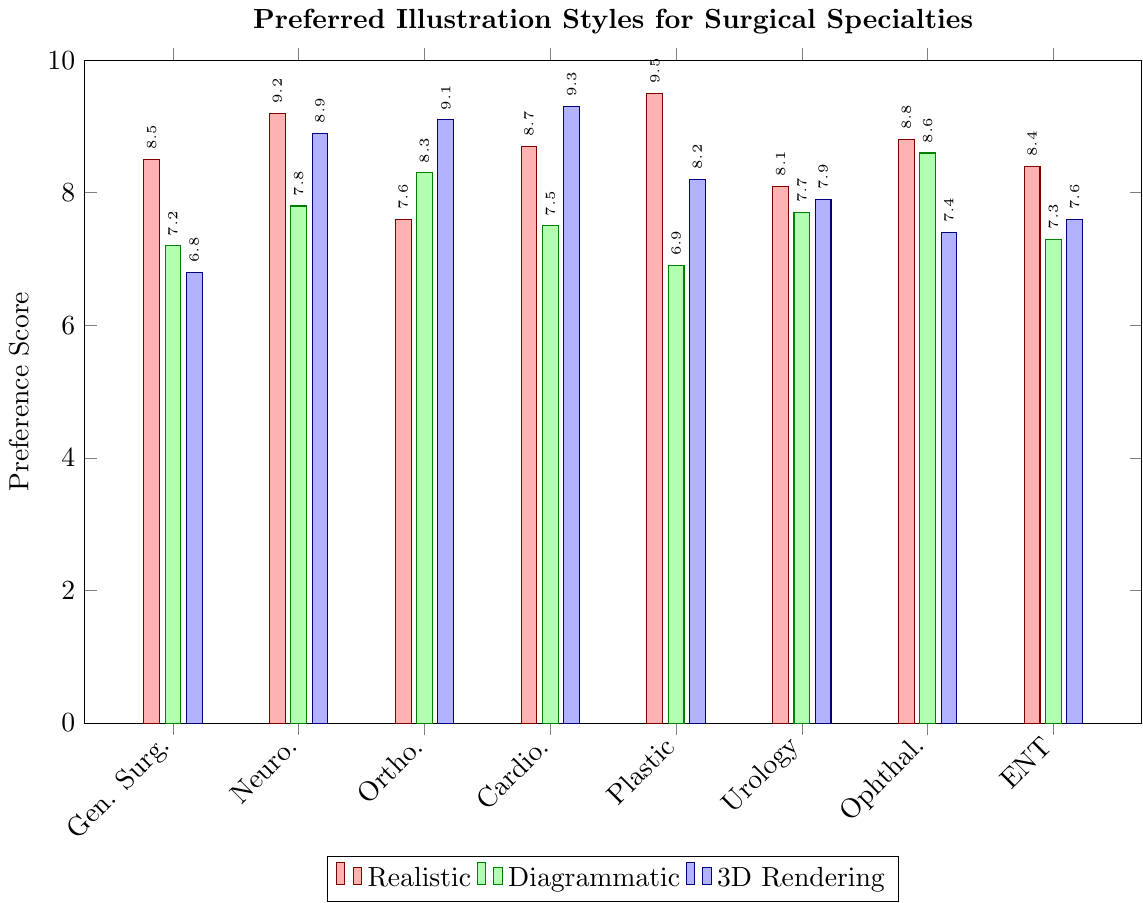Which surgical specialty prefers the realistic illustration style the most? To find the surgical specialty that prefers realistic illustrations the most, look at the "Realistic" bars and identify the tallest bar. The bar for Plastic Surgery is the tallest.
Answer: Plastic Surgery Which illustration style is least preferred by General Surgery? Look at the bars corresponding to General Surgery and identify the shortest one. The "3D Rendering" bar is the shortest for General Surgery.
Answer: 3D Rendering What's the average preference score for Neurosurgery across all illustration styles? Sum all preference scores for Neurosurgery and divide by the number of styles (3). Preference scores are 9.2 (Realistic), 7.8 (Diagrammatic), and 8.9 (3D Rendering). So, (9.2 + 7.8 + 8.9) / 3 = 25.9 / 3 = 8.63.
Answer: 8.63 Which specialty has the highest overall preference for 3D Rendering? To find this, look at the "3D Rendering" bars and identify the tallest one. The tallest "3D Rendering" bar corresponds to Cardiothoracic Surgery.
Answer: Cardiothoracic Surgery How does the preference for Diagrammatic illustrations in Urology compare with that in Ophthalmology? Compare the height of the "Diagrammatic" bars for Urology and Ophthalmology. Urology's score is 7.7, while Ophthalmology's score is 8.6. 8.6 is greater than 7.7.
Answer: Ophthalmology prefers it more What is the total preference score for all illustration styles in ENT? Sum up all the preference scores for ENT: 8.4 (Realistic) + 7.3 (Diagrammatic) + 7.6 (3D Rendering) = 23.3.
Answer: 23.3 Which illustration style has the most consistent preference scores across all specialties? Determine this by looking at the range (difference between the highest and lowest values) of each style's scores. "Realistic" ranges from 7.6 to 9.5, "Diagrammatic" ranges from 6.9 to 8.6, and "3D Rendering" ranges from 6.8 to 9.3. The narrowest range is for "Diagrammatic" (1.7).
Answer: Diagrammatic How much higher is the preference for 3D Rendering in Orthopedics compared to Diagrammatic in the same specialty? Subtract the preference score for Diagrammatic from the score for 3D Rendering in Orthopedics: 9.1 (3D Rendering) - 8.3 (Diagrammatic) = 0.8.
Answer: 0.8 